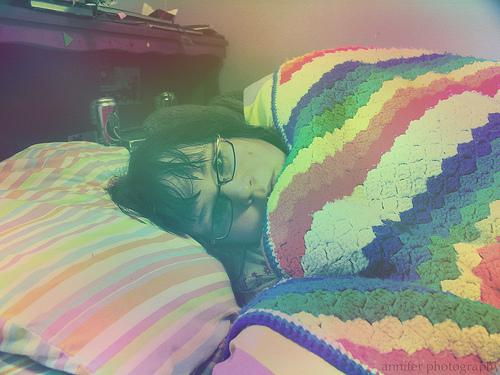Question: what is the woman laying her head on?
Choices:
A. Her boyfriends shoulder.
B. On the arm rest.
C. The table.
D. A pillow.
Answer with the letter. Answer: D Question: what color is the afghan covering the woman?
Choices:
A. White.
B. Blue.
C. Black.
D. Rainbow colored.
Answer with the letter. Answer: D 